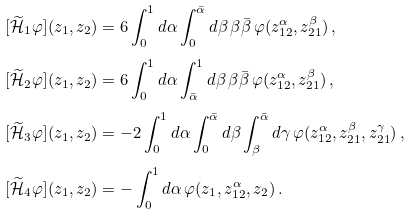<formula> <loc_0><loc_0><loc_500><loc_500>[ \widetilde { \mathcal { H } } _ { 1 } \varphi ] ( z _ { 1 } , z _ { 2 } ) & = 6 \int _ { 0 } ^ { 1 } d \alpha \int _ { 0 } ^ { \bar { \alpha } } d \beta \, \beta \bar { \beta } \, \varphi ( z _ { 1 2 } ^ { \alpha } , z _ { 2 1 } ^ { \beta } ) \, , \\ [ \widetilde { \mathcal { H } } _ { 2 } \varphi ] ( z _ { 1 } , z _ { 2 } ) & = 6 \int _ { 0 } ^ { 1 } d \alpha \int _ { \bar { \alpha } } ^ { 1 } d \beta \, \beta \bar { \beta } \, \varphi ( z _ { 1 2 } ^ { \alpha } , z _ { 2 1 } ^ { \beta } ) \, , \\ [ \widetilde { \mathcal { H } } _ { 3 } \varphi ] ( z _ { 1 } , z _ { 2 } ) & = - 2 \int _ { 0 } ^ { 1 } d \alpha \int _ { 0 } ^ { \bar { \alpha } } d \beta \int _ { \beta } ^ { \bar { \alpha } } d \gamma \, \varphi ( z _ { 1 2 } ^ { \alpha } , z _ { 2 1 } ^ { \beta } , z _ { 2 1 } ^ { \gamma } ) \, , \\ [ \widetilde { \mathcal { H } } _ { 4 } \varphi ] ( z _ { 1 } , z _ { 2 } ) & = - \int _ { 0 } ^ { 1 } d \alpha \, \varphi ( z _ { 1 } , z _ { 1 2 } ^ { \alpha } , z _ { 2 } ) \, .</formula> 